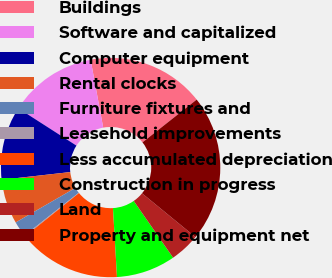Convert chart. <chart><loc_0><loc_0><loc_500><loc_500><pie_chart><fcel>Buildings<fcel>Software and capitalized<fcel>Computer equipment<fcel>Rental clocks<fcel>Furniture fixtures and<fcel>Leasehold improvements<fcel>Less accumulated depreciation<fcel>Construction in progress<fcel>Land<fcel>Property and equipment net<nl><fcel>17.28%<fcel>13.0%<fcel>10.86%<fcel>6.57%<fcel>2.29%<fcel>0.15%<fcel>15.14%<fcel>8.72%<fcel>4.43%<fcel>21.56%<nl></chart> 